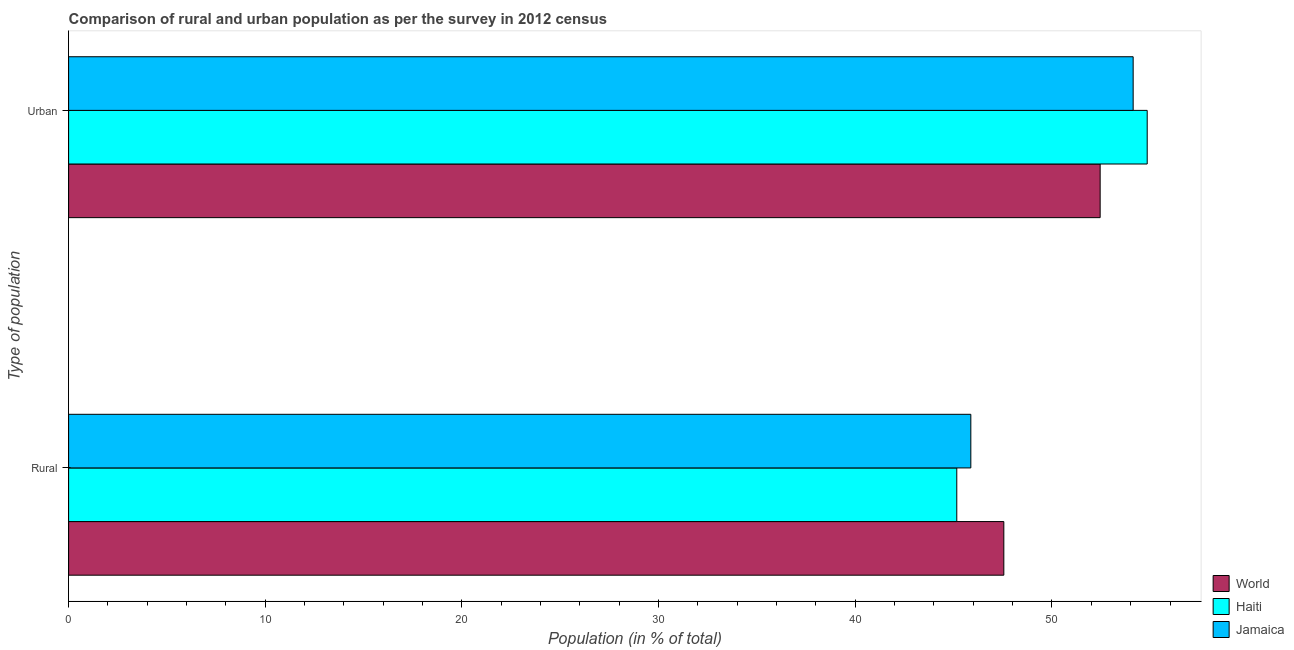How many groups of bars are there?
Offer a terse response. 2. How many bars are there on the 2nd tick from the bottom?
Ensure brevity in your answer.  3. What is the label of the 1st group of bars from the top?
Provide a succinct answer. Urban. What is the urban population in Jamaica?
Offer a terse response. 54.13. Across all countries, what is the maximum urban population?
Offer a terse response. 54.84. Across all countries, what is the minimum rural population?
Offer a terse response. 45.16. In which country was the rural population maximum?
Your response must be concise. World. In which country was the urban population minimum?
Your response must be concise. World. What is the total rural population in the graph?
Make the answer very short. 138.58. What is the difference between the urban population in World and that in Jamaica?
Provide a succinct answer. -1.68. What is the difference between the rural population in World and the urban population in Haiti?
Your answer should be compact. -7.29. What is the average rural population per country?
Ensure brevity in your answer.  46.19. What is the difference between the urban population and rural population in World?
Offer a very short reply. 4.9. What is the ratio of the urban population in Haiti to that in World?
Give a very brief answer. 1.05. Is the rural population in Haiti less than that in Jamaica?
Your answer should be compact. Yes. In how many countries, is the urban population greater than the average urban population taken over all countries?
Give a very brief answer. 2. What does the 1st bar from the top in Urban represents?
Your answer should be very brief. Jamaica. What does the 3rd bar from the bottom in Rural represents?
Provide a succinct answer. Jamaica. Does the graph contain any zero values?
Ensure brevity in your answer.  No. Where does the legend appear in the graph?
Your response must be concise. Bottom right. How many legend labels are there?
Your answer should be compact. 3. What is the title of the graph?
Give a very brief answer. Comparison of rural and urban population as per the survey in 2012 census. What is the label or title of the X-axis?
Your response must be concise. Population (in % of total). What is the label or title of the Y-axis?
Give a very brief answer. Type of population. What is the Population (in % of total) of World in Rural?
Provide a succinct answer. 47.55. What is the Population (in % of total) in Haiti in Rural?
Your answer should be compact. 45.16. What is the Population (in % of total) of Jamaica in Rural?
Provide a short and direct response. 45.87. What is the Population (in % of total) in World in Urban?
Offer a very short reply. 52.45. What is the Population (in % of total) in Haiti in Urban?
Your response must be concise. 54.84. What is the Population (in % of total) in Jamaica in Urban?
Your answer should be very brief. 54.13. Across all Type of population, what is the maximum Population (in % of total) of World?
Offer a very short reply. 52.45. Across all Type of population, what is the maximum Population (in % of total) of Haiti?
Give a very brief answer. 54.84. Across all Type of population, what is the maximum Population (in % of total) of Jamaica?
Give a very brief answer. 54.13. Across all Type of population, what is the minimum Population (in % of total) in World?
Your answer should be very brief. 47.55. Across all Type of population, what is the minimum Population (in % of total) in Haiti?
Offer a very short reply. 45.16. Across all Type of population, what is the minimum Population (in % of total) in Jamaica?
Offer a very short reply. 45.87. What is the total Population (in % of total) of World in the graph?
Ensure brevity in your answer.  100. What is the total Population (in % of total) in Haiti in the graph?
Offer a very short reply. 100. What is the difference between the Population (in % of total) of World in Rural and that in Urban?
Your response must be concise. -4.9. What is the difference between the Population (in % of total) in Haiti in Rural and that in Urban?
Offer a very short reply. -9.68. What is the difference between the Population (in % of total) of Jamaica in Rural and that in Urban?
Provide a succinct answer. -8.25. What is the difference between the Population (in % of total) in World in Rural and the Population (in % of total) in Haiti in Urban?
Make the answer very short. -7.29. What is the difference between the Population (in % of total) in World in Rural and the Population (in % of total) in Jamaica in Urban?
Offer a very short reply. -6.58. What is the difference between the Population (in % of total) in Haiti in Rural and the Population (in % of total) in Jamaica in Urban?
Your answer should be compact. -8.97. What is the average Population (in % of total) in World per Type of population?
Offer a terse response. 50. What is the average Population (in % of total) of Jamaica per Type of population?
Your answer should be compact. 50. What is the difference between the Population (in % of total) in World and Population (in % of total) in Haiti in Rural?
Make the answer very short. 2.39. What is the difference between the Population (in % of total) of World and Population (in % of total) of Jamaica in Rural?
Keep it short and to the point. 1.68. What is the difference between the Population (in % of total) in Haiti and Population (in % of total) in Jamaica in Rural?
Offer a terse response. -0.71. What is the difference between the Population (in % of total) in World and Population (in % of total) in Haiti in Urban?
Make the answer very short. -2.39. What is the difference between the Population (in % of total) in World and Population (in % of total) in Jamaica in Urban?
Your response must be concise. -1.68. What is the difference between the Population (in % of total) of Haiti and Population (in % of total) of Jamaica in Urban?
Keep it short and to the point. 0.71. What is the ratio of the Population (in % of total) in World in Rural to that in Urban?
Give a very brief answer. 0.91. What is the ratio of the Population (in % of total) of Haiti in Rural to that in Urban?
Make the answer very short. 0.82. What is the ratio of the Population (in % of total) of Jamaica in Rural to that in Urban?
Make the answer very short. 0.85. What is the difference between the highest and the second highest Population (in % of total) in World?
Make the answer very short. 4.9. What is the difference between the highest and the second highest Population (in % of total) of Haiti?
Provide a succinct answer. 9.68. What is the difference between the highest and the second highest Population (in % of total) of Jamaica?
Provide a short and direct response. 8.25. What is the difference between the highest and the lowest Population (in % of total) of World?
Give a very brief answer. 4.9. What is the difference between the highest and the lowest Population (in % of total) in Haiti?
Your response must be concise. 9.68. What is the difference between the highest and the lowest Population (in % of total) of Jamaica?
Offer a terse response. 8.25. 